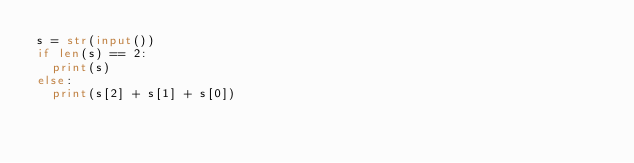<code> <loc_0><loc_0><loc_500><loc_500><_Python_>s = str(input())
if len(s) == 2:
  print(s)
else:
  print(s[2] + s[1] + s[0])
</code> 